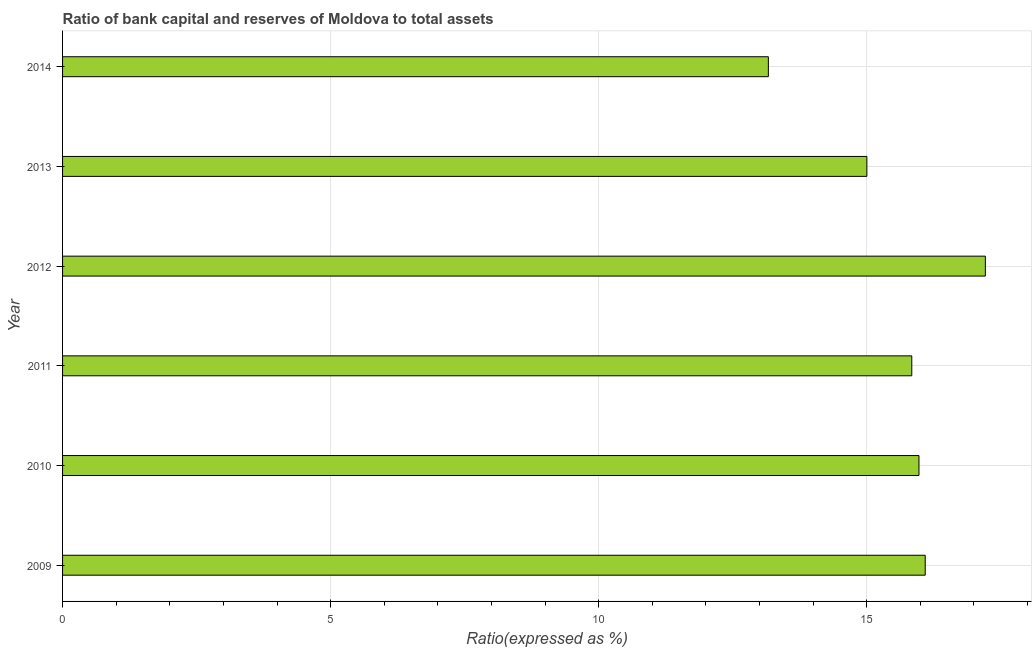What is the title of the graph?
Provide a short and direct response. Ratio of bank capital and reserves of Moldova to total assets. What is the label or title of the X-axis?
Keep it short and to the point. Ratio(expressed as %). What is the label or title of the Y-axis?
Ensure brevity in your answer.  Year. What is the bank capital to assets ratio in 2010?
Your answer should be very brief. 15.98. Across all years, what is the maximum bank capital to assets ratio?
Offer a terse response. 17.21. Across all years, what is the minimum bank capital to assets ratio?
Keep it short and to the point. 13.17. In which year was the bank capital to assets ratio minimum?
Provide a short and direct response. 2014. What is the sum of the bank capital to assets ratio?
Keep it short and to the point. 93.29. What is the difference between the bank capital to assets ratio in 2009 and 2013?
Provide a succinct answer. 1.09. What is the average bank capital to assets ratio per year?
Your answer should be compact. 15.55. What is the median bank capital to assets ratio?
Provide a short and direct response. 15.91. What is the ratio of the bank capital to assets ratio in 2010 to that in 2013?
Your response must be concise. 1.06. Is the bank capital to assets ratio in 2011 less than that in 2014?
Keep it short and to the point. No. What is the difference between the highest and the second highest bank capital to assets ratio?
Your answer should be compact. 1.12. What is the difference between the highest and the lowest bank capital to assets ratio?
Provide a succinct answer. 4.05. How many bars are there?
Provide a short and direct response. 6. What is the Ratio(expressed as %) in 2009?
Keep it short and to the point. 16.09. What is the Ratio(expressed as %) in 2010?
Provide a short and direct response. 15.98. What is the Ratio(expressed as %) in 2011?
Provide a succinct answer. 15.84. What is the Ratio(expressed as %) of 2012?
Your response must be concise. 17.21. What is the Ratio(expressed as %) in 2013?
Make the answer very short. 15. What is the Ratio(expressed as %) of 2014?
Your answer should be very brief. 13.17. What is the difference between the Ratio(expressed as %) in 2009 and 2010?
Provide a succinct answer. 0.12. What is the difference between the Ratio(expressed as %) in 2009 and 2011?
Your response must be concise. 0.25. What is the difference between the Ratio(expressed as %) in 2009 and 2012?
Keep it short and to the point. -1.12. What is the difference between the Ratio(expressed as %) in 2009 and 2013?
Your answer should be very brief. 1.09. What is the difference between the Ratio(expressed as %) in 2009 and 2014?
Offer a terse response. 2.93. What is the difference between the Ratio(expressed as %) in 2010 and 2011?
Provide a succinct answer. 0.13. What is the difference between the Ratio(expressed as %) in 2010 and 2012?
Give a very brief answer. -1.24. What is the difference between the Ratio(expressed as %) in 2010 and 2013?
Your answer should be very brief. 0.97. What is the difference between the Ratio(expressed as %) in 2010 and 2014?
Keep it short and to the point. 2.81. What is the difference between the Ratio(expressed as %) in 2011 and 2012?
Your response must be concise. -1.37. What is the difference between the Ratio(expressed as %) in 2011 and 2013?
Offer a very short reply. 0.84. What is the difference between the Ratio(expressed as %) in 2011 and 2014?
Offer a very short reply. 2.68. What is the difference between the Ratio(expressed as %) in 2012 and 2013?
Make the answer very short. 2.21. What is the difference between the Ratio(expressed as %) in 2012 and 2014?
Your answer should be very brief. 4.05. What is the difference between the Ratio(expressed as %) in 2013 and 2014?
Your response must be concise. 1.84. What is the ratio of the Ratio(expressed as %) in 2009 to that in 2010?
Your answer should be very brief. 1.01. What is the ratio of the Ratio(expressed as %) in 2009 to that in 2011?
Keep it short and to the point. 1.02. What is the ratio of the Ratio(expressed as %) in 2009 to that in 2012?
Your answer should be very brief. 0.94. What is the ratio of the Ratio(expressed as %) in 2009 to that in 2013?
Your response must be concise. 1.07. What is the ratio of the Ratio(expressed as %) in 2009 to that in 2014?
Keep it short and to the point. 1.22. What is the ratio of the Ratio(expressed as %) in 2010 to that in 2012?
Provide a succinct answer. 0.93. What is the ratio of the Ratio(expressed as %) in 2010 to that in 2013?
Ensure brevity in your answer.  1.06. What is the ratio of the Ratio(expressed as %) in 2010 to that in 2014?
Offer a terse response. 1.21. What is the ratio of the Ratio(expressed as %) in 2011 to that in 2013?
Offer a very short reply. 1.06. What is the ratio of the Ratio(expressed as %) in 2011 to that in 2014?
Your response must be concise. 1.2. What is the ratio of the Ratio(expressed as %) in 2012 to that in 2013?
Offer a very short reply. 1.15. What is the ratio of the Ratio(expressed as %) in 2012 to that in 2014?
Provide a short and direct response. 1.31. What is the ratio of the Ratio(expressed as %) in 2013 to that in 2014?
Offer a terse response. 1.14. 